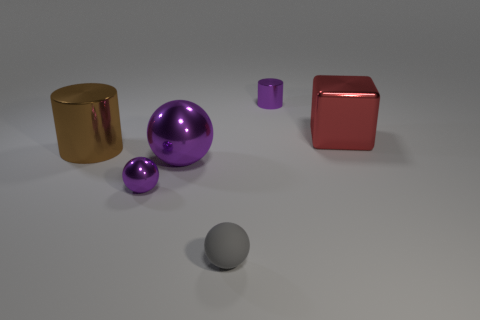Add 3 big red objects. How many objects exist? 9 Subtract all purple balls. How many balls are left? 1 Subtract all tiny purple spheres. How many spheres are left? 2 Subtract all blocks. How many objects are left? 5 Subtract all brown cylinders. How many yellow blocks are left? 0 Subtract all tiny metal things. Subtract all purple metal balls. How many objects are left? 2 Add 4 tiny gray balls. How many tiny gray balls are left? 5 Add 2 small gray metal blocks. How many small gray metal blocks exist? 2 Subtract 0 yellow balls. How many objects are left? 6 Subtract 1 cylinders. How many cylinders are left? 1 